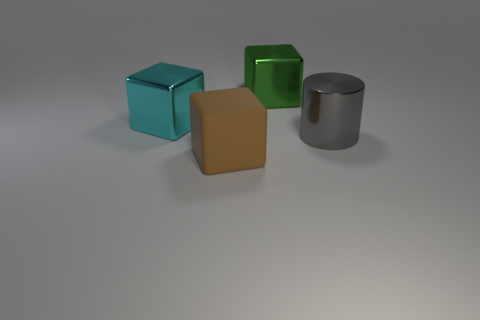Subtract all big metal cubes. How many cubes are left? 1 Add 1 big purple metallic objects. How many objects exist? 5 Subtract all brown blocks. How many blocks are left? 2 Subtract all blocks. How many objects are left? 1 Subtract all gray cubes. Subtract all purple cylinders. How many cubes are left? 3 Subtract all brown cylinders. How many brown cubes are left? 1 Subtract all big metal cubes. Subtract all big cyan things. How many objects are left? 1 Add 2 large gray shiny cylinders. How many large gray shiny cylinders are left? 3 Add 1 big blocks. How many big blocks exist? 4 Subtract 0 gray blocks. How many objects are left? 4 